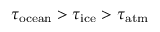<formula> <loc_0><loc_0><loc_500><loc_500>\tau _ { o c e a n } > \tau _ { i c e } > \tau _ { a t m }</formula> 